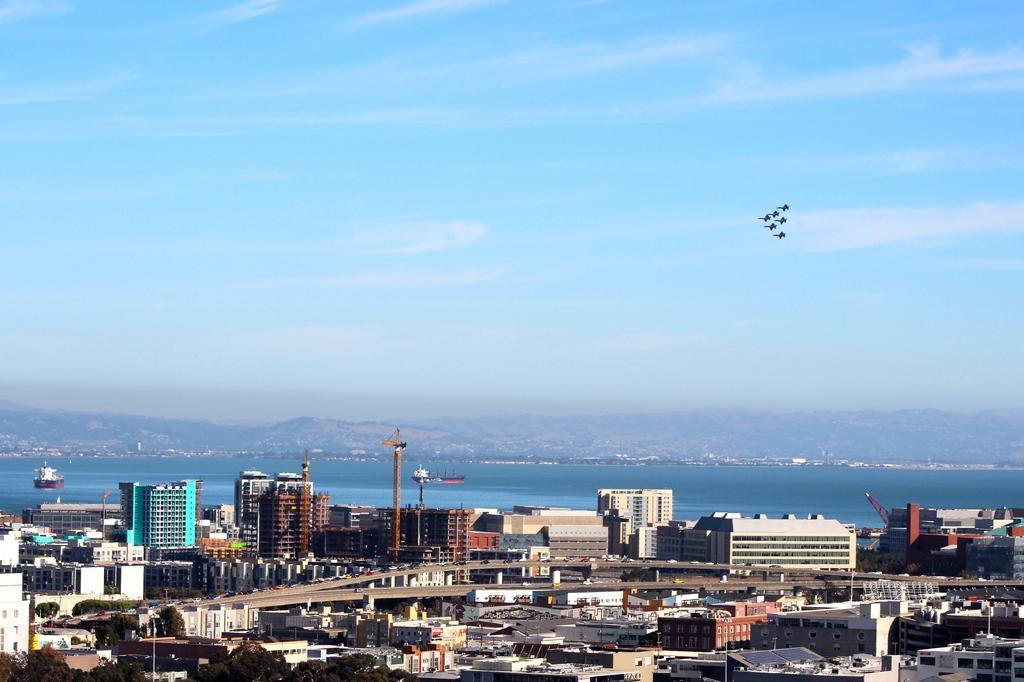Can you describe this image briefly? In this image we can see buildings, hills, water and we can also see something flying in the sky. 